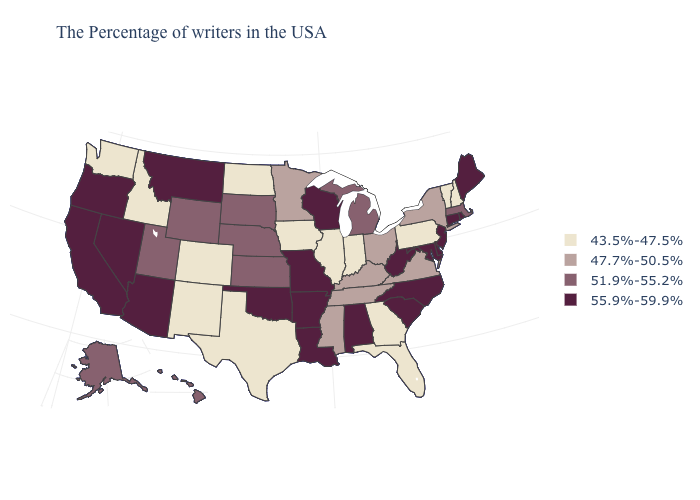What is the highest value in the Northeast ?
Write a very short answer. 55.9%-59.9%. Among the states that border New Jersey , does Delaware have the highest value?
Short answer required. Yes. What is the lowest value in the USA?
Keep it brief. 43.5%-47.5%. Does Maine have the lowest value in the USA?
Write a very short answer. No. Name the states that have a value in the range 55.9%-59.9%?
Write a very short answer. Maine, Rhode Island, Connecticut, New Jersey, Delaware, Maryland, North Carolina, South Carolina, West Virginia, Alabama, Wisconsin, Louisiana, Missouri, Arkansas, Oklahoma, Montana, Arizona, Nevada, California, Oregon. Does the map have missing data?
Answer briefly. No. Among the states that border Washington , does Oregon have the lowest value?
Answer briefly. No. Among the states that border Mississippi , which have the lowest value?
Short answer required. Tennessee. Which states have the lowest value in the USA?
Be succinct. New Hampshire, Vermont, Pennsylvania, Florida, Georgia, Indiana, Illinois, Iowa, Texas, North Dakota, Colorado, New Mexico, Idaho, Washington. Does Mississippi have the lowest value in the USA?
Write a very short answer. No. What is the lowest value in states that border Connecticut?
Keep it brief. 47.7%-50.5%. What is the value of Hawaii?
Write a very short answer. 51.9%-55.2%. Which states hav the highest value in the MidWest?
Answer briefly. Wisconsin, Missouri. What is the highest value in states that border New York?
Be succinct. 55.9%-59.9%. Name the states that have a value in the range 51.9%-55.2%?
Write a very short answer. Massachusetts, Michigan, Kansas, Nebraska, South Dakota, Wyoming, Utah, Alaska, Hawaii. 